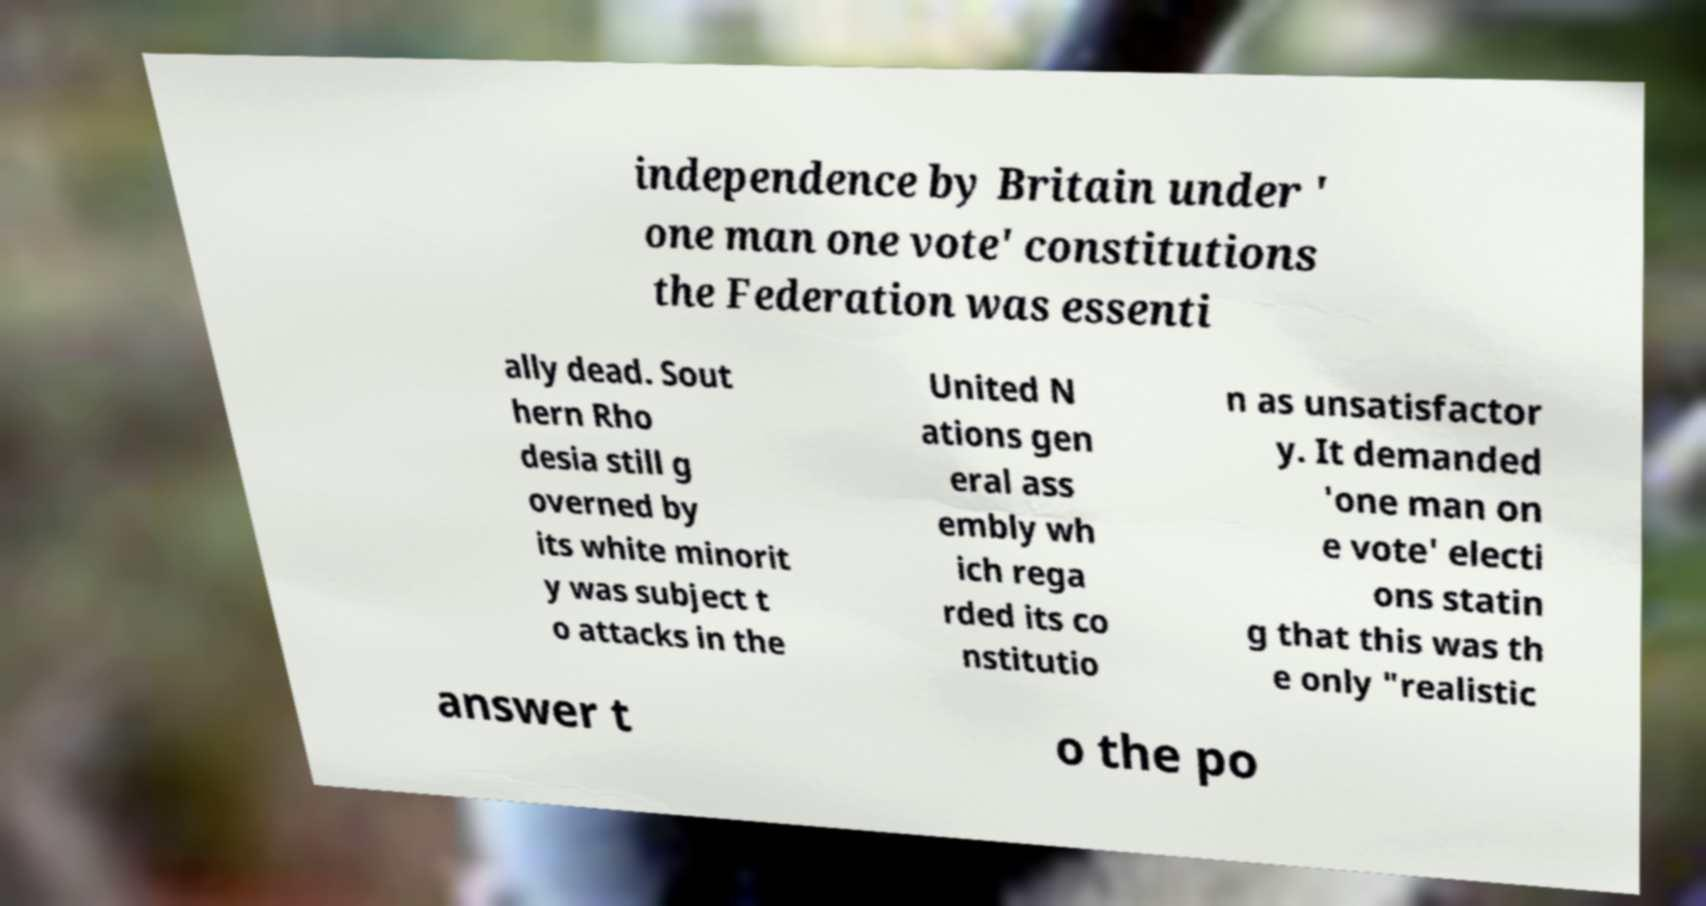Please read and relay the text visible in this image. What does it say? independence by Britain under ' one man one vote' constitutions the Federation was essenti ally dead. Sout hern Rho desia still g overned by its white minorit y was subject t o attacks in the United N ations gen eral ass embly wh ich rega rded its co nstitutio n as unsatisfactor y. It demanded 'one man on e vote' electi ons statin g that this was th e only "realistic answer t o the po 